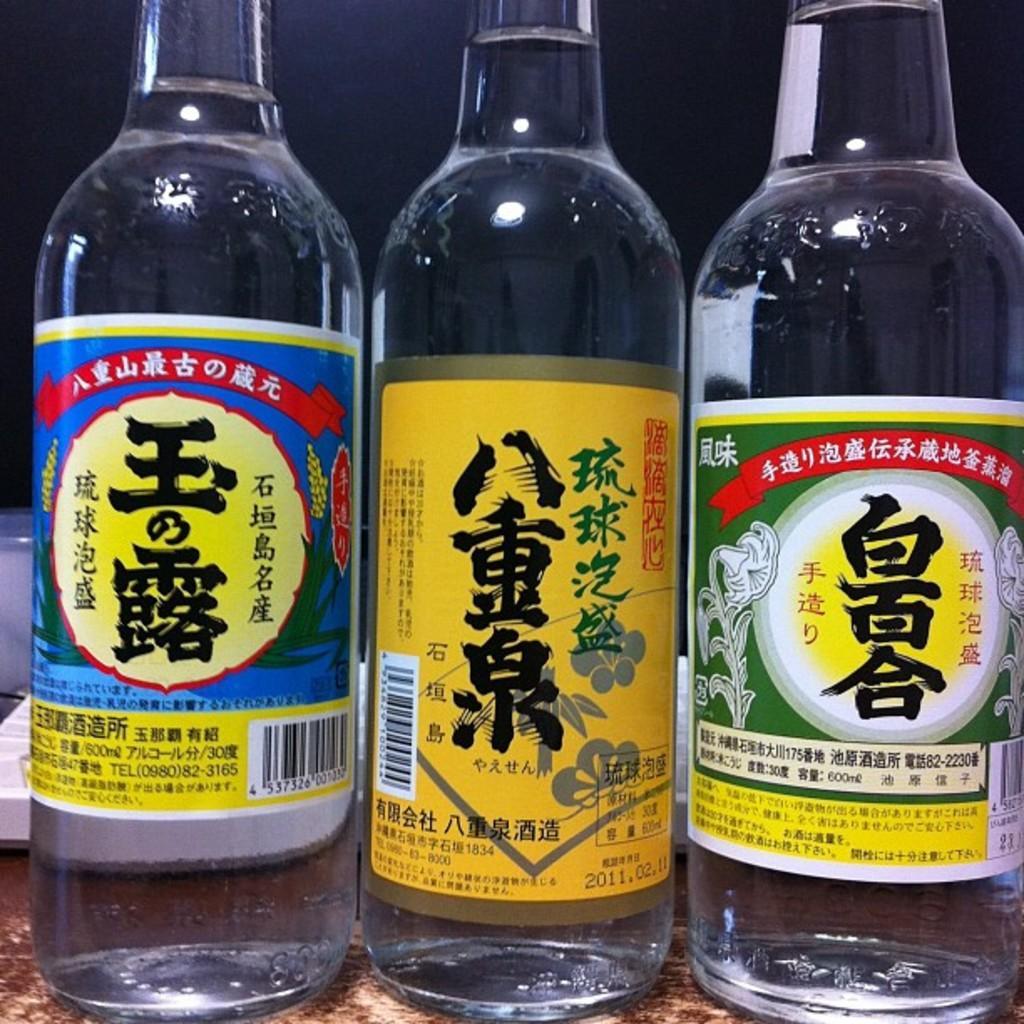How would you summarize this image in a sentence or two? In this image there are three water bottles. 